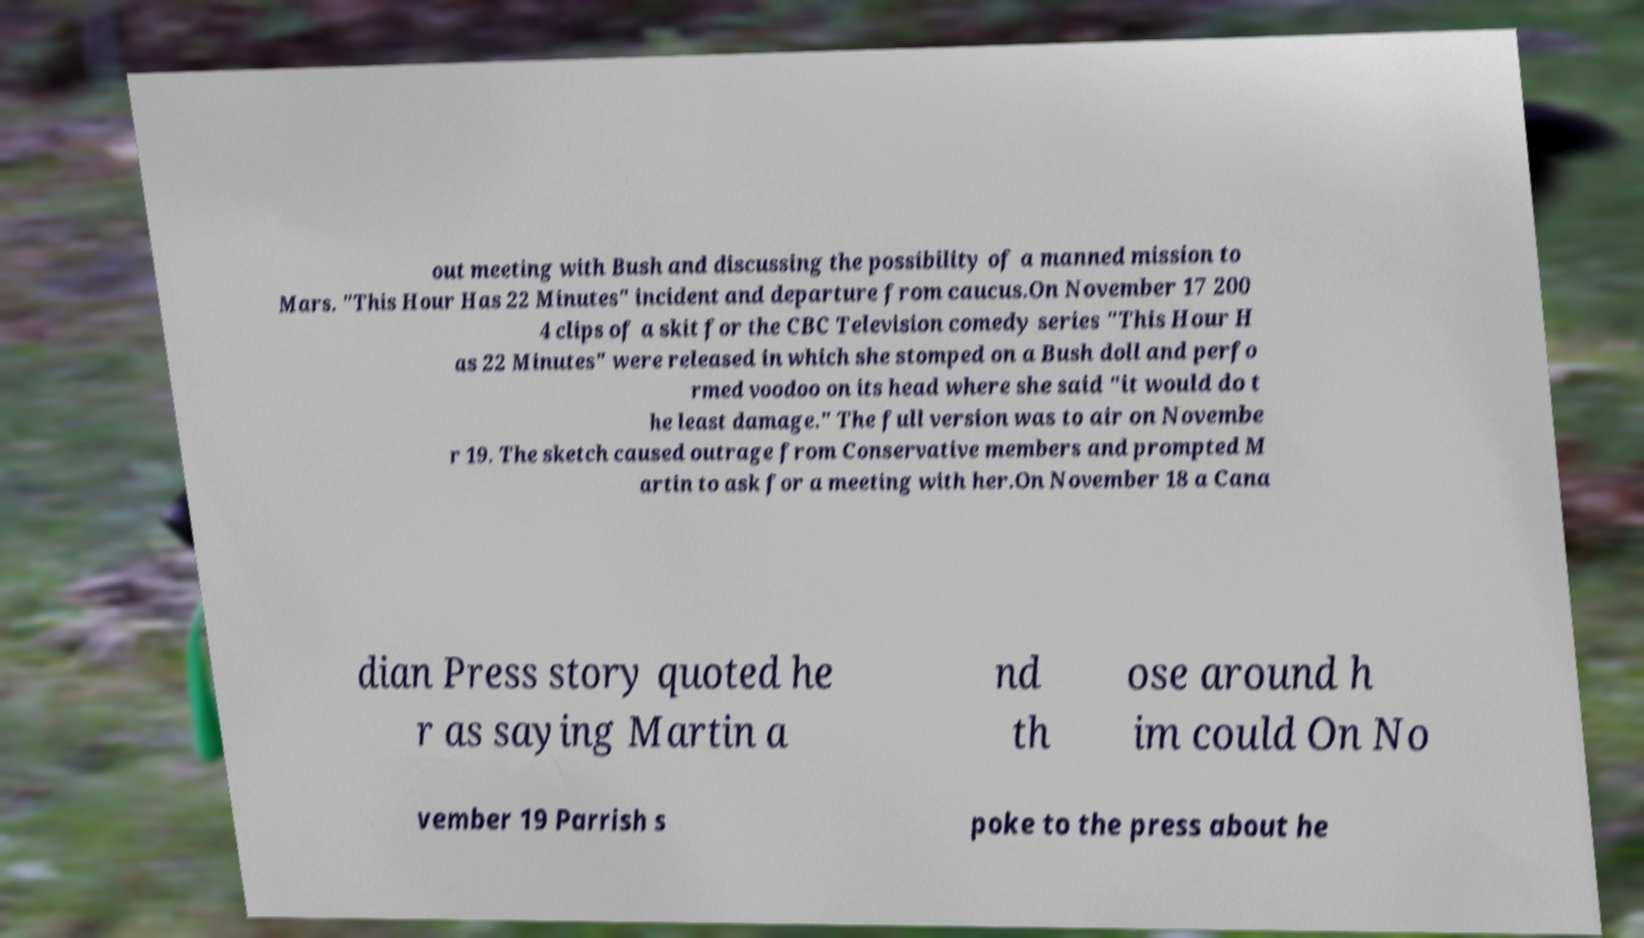There's text embedded in this image that I need extracted. Can you transcribe it verbatim? out meeting with Bush and discussing the possibility of a manned mission to Mars. "This Hour Has 22 Minutes" incident and departure from caucus.On November 17 200 4 clips of a skit for the CBC Television comedy series "This Hour H as 22 Minutes" were released in which she stomped on a Bush doll and perfo rmed voodoo on its head where she said "it would do t he least damage." The full version was to air on Novembe r 19. The sketch caused outrage from Conservative members and prompted M artin to ask for a meeting with her.On November 18 a Cana dian Press story quoted he r as saying Martin a nd th ose around h im could On No vember 19 Parrish s poke to the press about he 